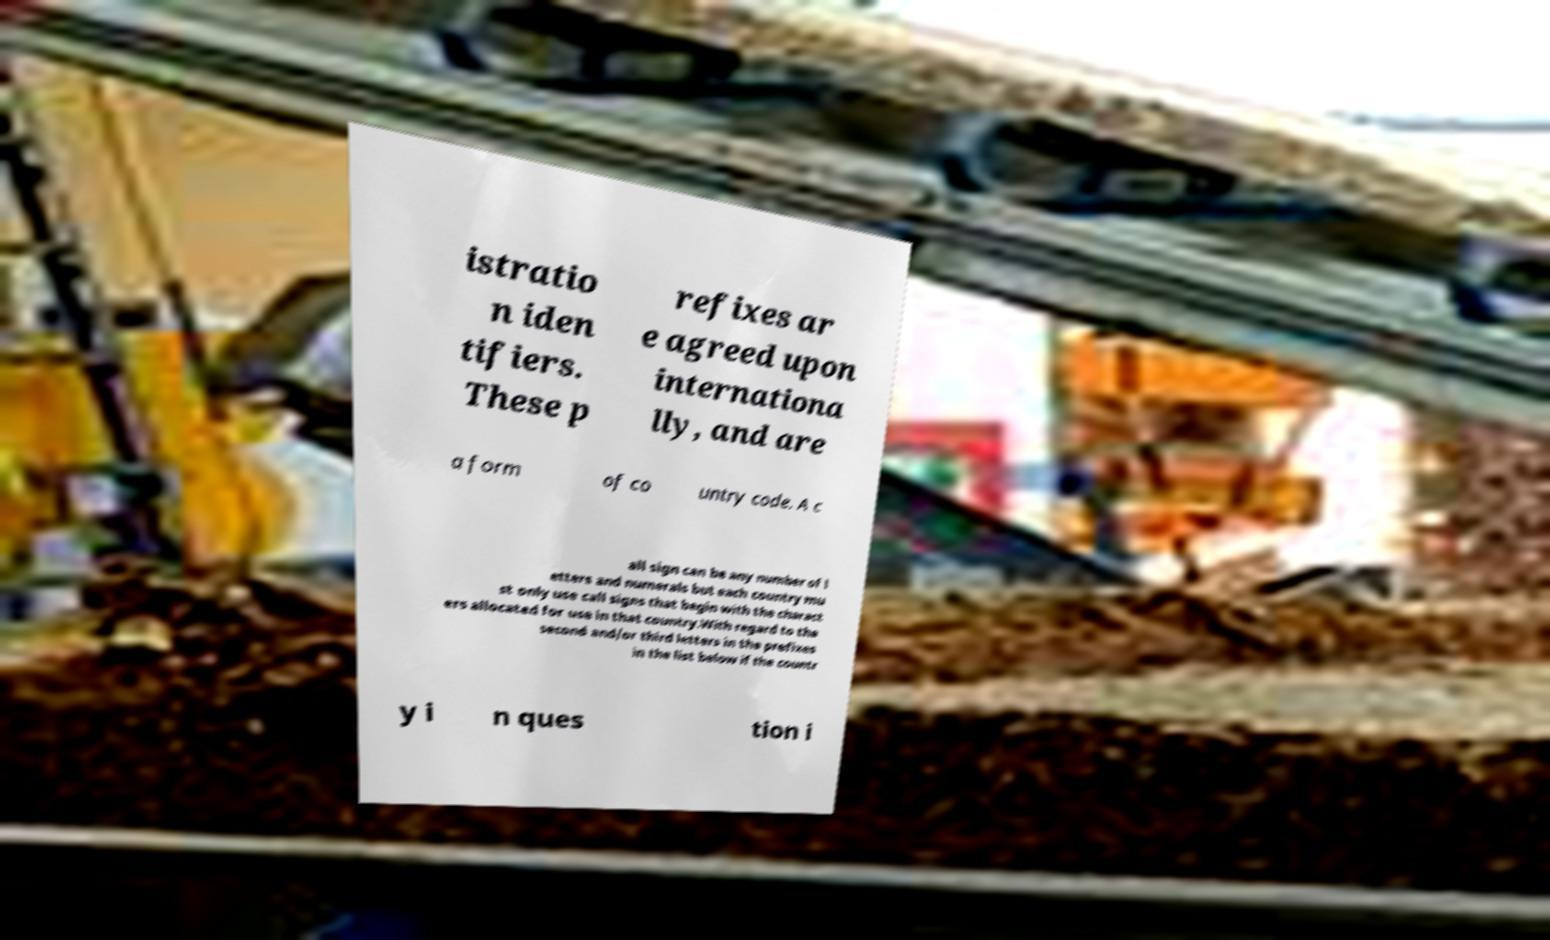Please identify and transcribe the text found in this image. istratio n iden tifiers. These p refixes ar e agreed upon internationa lly, and are a form of co untry code. A c all sign can be any number of l etters and numerals but each country mu st only use call signs that begin with the charact ers allocated for use in that country.With regard to the second and/or third letters in the prefixes in the list below if the countr y i n ques tion i 